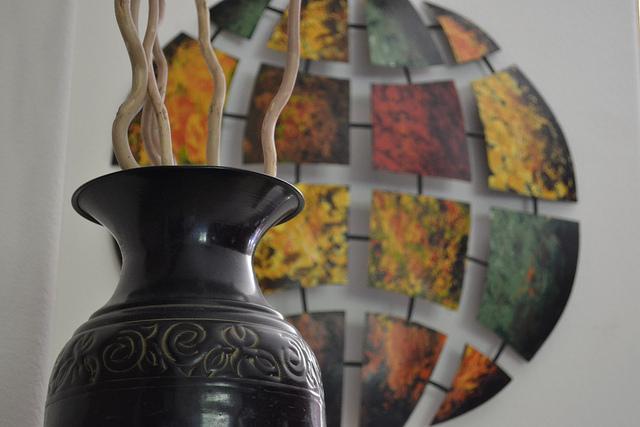Who gave this vase?
Concise answer only. Friend. Is something growing in the vase?
Concise answer only. Yes. What color is the vase?
Write a very short answer. Black. What is the primary color on this vase?
Keep it brief. Black. Is the art on the wall, mainly red or orange?
Write a very short answer. Orange. What is this picture on?
Keep it brief. Wall. What is in the vase?
Short answer required. Plant. 